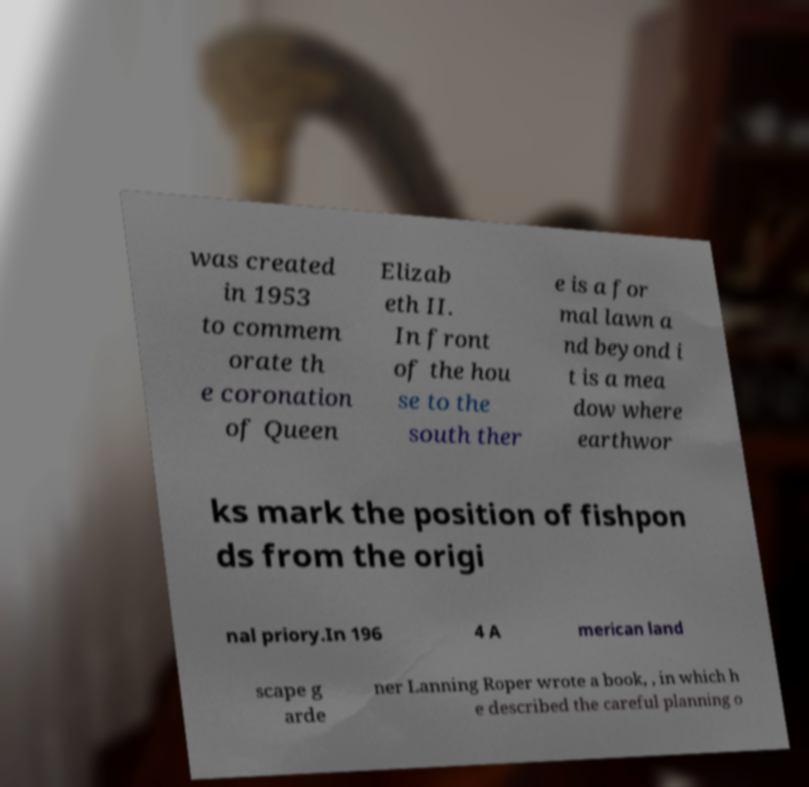Could you assist in decoding the text presented in this image and type it out clearly? was created in 1953 to commem orate th e coronation of Queen Elizab eth II. In front of the hou se to the south ther e is a for mal lawn a nd beyond i t is a mea dow where earthwor ks mark the position of fishpon ds from the origi nal priory.In 196 4 A merican land scape g arde ner Lanning Roper wrote a book, , in which h e described the careful planning o 